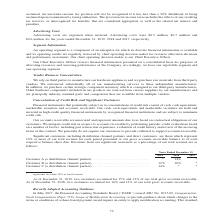Looking at A10 Networks's financial data, please calculate: What is the proportion of revenue derived from significant customers in 2019? Based on the calculation: 12% + 14% , the result is 26 (percentage). This is based on the information: "% * Customer B (a distribution channel partner) . 12% 10% * Customer C (a distribution channel partner) . 14% * * Customer A (a distribution channel partner). . * 14% * Customer B (a distribution chan..." The key data points involved are: 12, 14. Also, What are some examples of financial instruments that can subject the company to credit risk? cash, cash equivalents, marketable securities and accounts receivable. The document states: "ct us to concentrations of credit risk consist of cash, cash equivalents, marketable securities and accounts receivable. Our cash, cash equivalents an..." Also, How does the company mitigate its credit risk pertaining to accounts receivable? performing periodic credit evaluations based on a number of factors, including past transaction experience, evaluation of credit history and review of the invoicing terms of the contract. The document states: "credit risk in respect to accounts receivable by performing periodic credit evaluations based on a number of factors, including past transaction exper..." Also, can you calculate: What is the total proportion from Customer B and C of the company's gross accounts receivable  in 2019? Based on the calculation: 17+12, the result is 29 (percentage). This is based on the information: "% * Customer B (a distribution channel partner) . 12% 10% * Customer C (a distribution channel partner) . 14% * * % * Customer B (a distribution channel partner) . 12% 10% * Customer C (a distribution..." The key data points involved are: 12, 17. Also, How does the company determine its significant customers? Significant customers, including distribution channel partners and direct customers, are those which represent 10% or more of our total revenue for each period presented or our gross accounts receivable balance as of each respective balance sheet date.. The document states: "Significant customers, including distribution channel partners and direct customers, are those which represent 10% or more of our total revenue for ea..." Also, can you calculate: What is the company's total revenue earned from Customer A and B between 2018 and 2019? Based on the calculation: 14 + 12+10, the result is 36 (percentage). This is based on the information: "Customer A (a distribution channel partner). . * 14% * Customer B (a distribution channel partner) . 12% 10% * Customer C (a distribution channel partn % * Customer B (a distribution channel partner) ..." The key data points involved are: 10, 12, 14. 